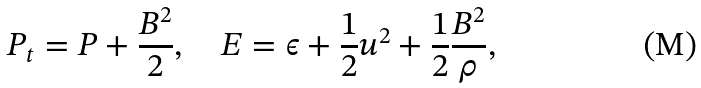Convert formula to latex. <formula><loc_0><loc_0><loc_500><loc_500>P _ { t } = P + \frac { B ^ { 2 } } { 2 } , \quad E = \epsilon + \frac { 1 } { 2 } u ^ { 2 } + \frac { 1 } { 2 } \frac { B ^ { 2 } } { \rho } ,</formula> 